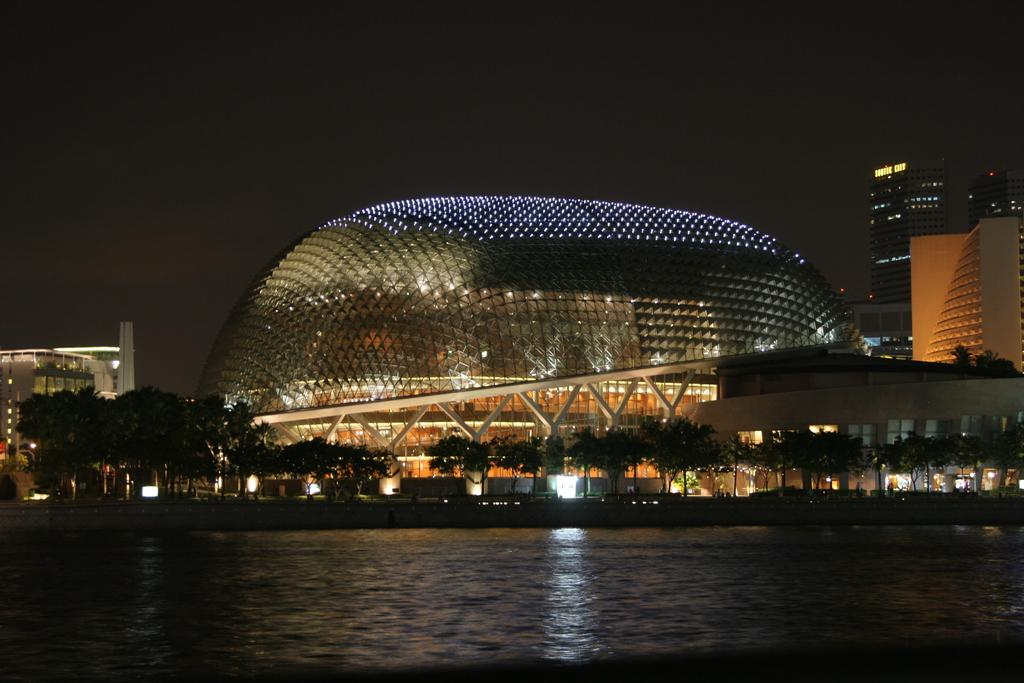What can be seen in the foreground of the image? There is water in the foreground of the image. What is located in the middle of the image? There are trees and buildings in the middle of the image. What else is present in the middle of the image? There are lights in the middle of the image. What is the condition of the sky in the image? The sky is dark at the top of the image. Where is the basin located in the image? There is no basin present in the image. What type of throne can be seen in the image? There is no throne present in the image. 